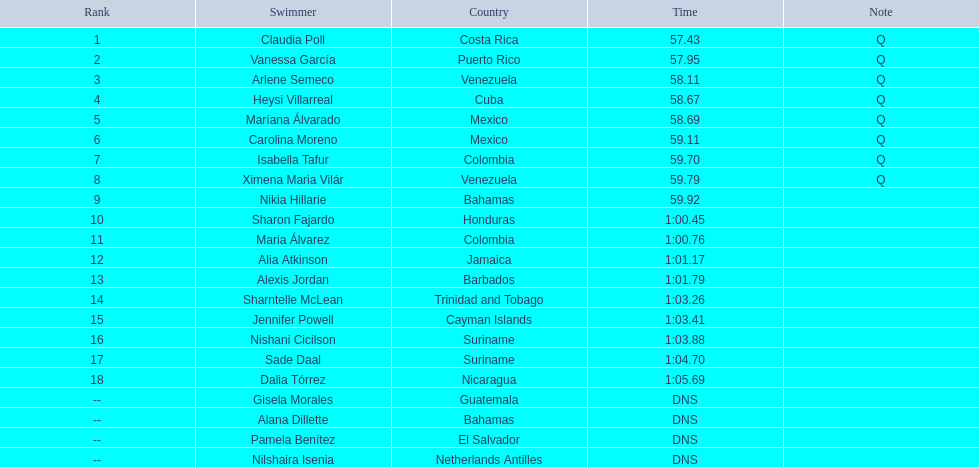Which countries were represented by the top eight contenders? Costa Rica, Puerto Rico, Venezuela, Cuba, Mexico, Mexico, Colombia, Venezuela. Was cuba among those nations? Heysi Villarreal. 